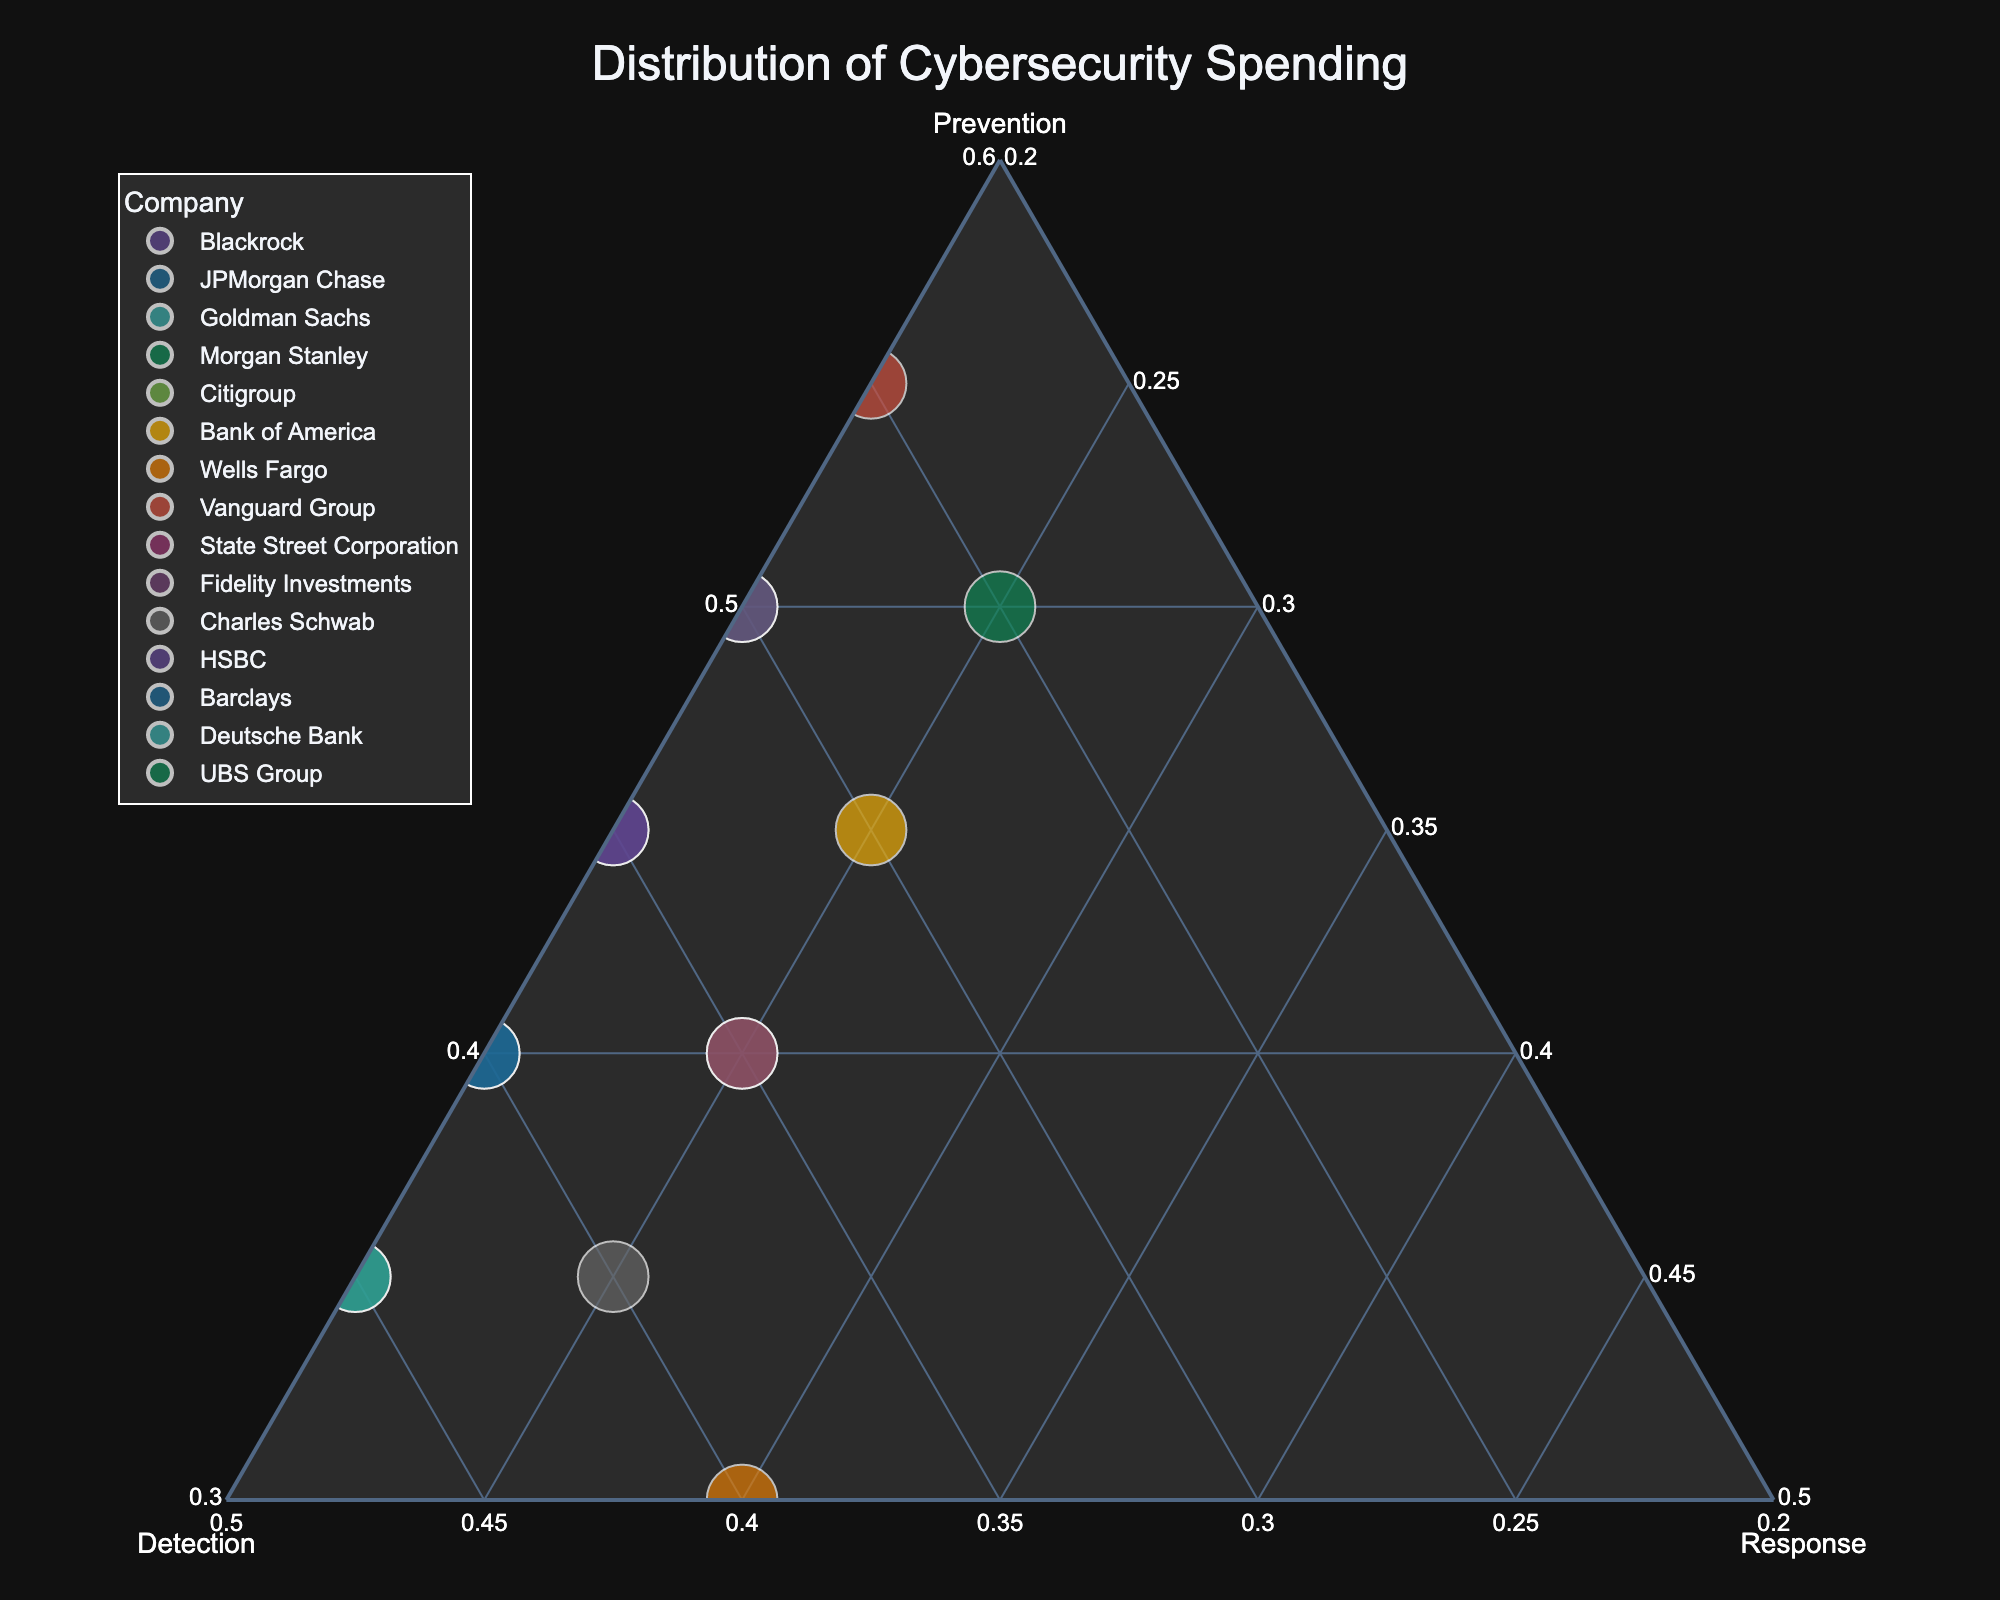What's the title of the plot? The title is generally found at the top of the plot and provides an overview of what the plot represents. In this case, the title mentions "Distribution of Cybersecurity Spending."
Answer: Distribution of Cybersecurity Spending How many companies are represented in the plot? Each company's name is a data point on the plot. By counting these unique names or points, you find the total number of companies.
Answer: 15 Which company has the highest prevention spending? Prevention spending is represented on the ternary plot with the 'Prevention' axis. By identifying the point farthest along this axis, you find the company with the highest prevention spending.
Answer: Vanguard Group Which two companies have the same spending distribution in detection and response but differ in prevention? By looking at the points that align closely on the Detection and Response axes but differ on the Prevention axis, we find the companies.
Answer: Vanguard Group and UBS Group What is the range of response spending percentages across all companies? Identify the minimum and maximum values along the Response axis in the plot, which shows the spending percentages for response measures. The range is the difference between these values.
Answer: 20%-30% What is the sum of spending percentages for Citigroup on prevention, detection, and response? Since the plot normalizes to 100%, the total sum of spending percentages for any company will be 100%. Verify by adding the Prevention, Detection, and Response spending percentages for Citigroup.
Answer: 100% Which company has the most balanced distribution of spending across prevention, detection, and response? A balanced distribution would be represented by a point near the center of the ternary plot. Identify the company located closest to the center.
Answer: Wells Fargo How does the spending on detection measures by Morgan Stanley compare to that of Charles Schwab? Locate the points for Morgan Stanley and Charles Schwab on the Detection axis and compare their positions to determine which has a higher or lower value.
Answer: Charles Schwab has higher detection spending What is the average spending on response measures for all companies? Sum the Response percentages for all companies and divide by the total number of companies to find the mean value. (20 + 20 + 20 + 20 + 25 + 25 + 30 + 20 + 25 + 20 + 25 + 20 + 20 + 20 + 25)/15 = 22.33
Answer: 22.33% For a company focused equally on detection and prevention, which company resembles this most? Look for a point on the plot where the Detection and Prevention values are approximately equal. This would be on the axis dividing these two regions.
Answer: JPMorgan Chase 